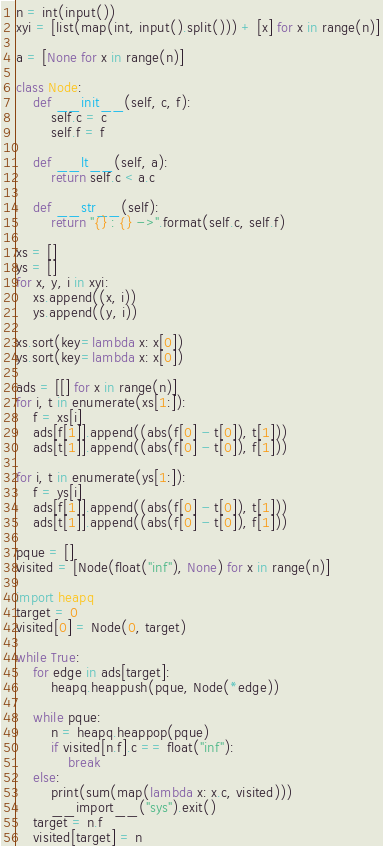<code> <loc_0><loc_0><loc_500><loc_500><_Python_>n = int(input())
xyi = [list(map(int, input().split())) + [x] for x in range(n)]

a = [None for x in range(n)]

class Node:
    def __init__(self, c, f):
        self.c = c
        self.f = f

    def __lt__(self, a):
        return self.c < a.c

    def __str__(self):
        return "{} : {} ->".format(self.c, self.f)

xs = []
ys = []
for x, y, i in xyi:
    xs.append((x, i))
    ys.append((y, i))

xs.sort(key=lambda x: x[0])
ys.sort(key=lambda x: x[0])

ads = [[] for x in range(n)]
for i, t in enumerate(xs[1:]):
    f = xs[i]
    ads[f[1]].append((abs(f[0] - t[0]), t[1]))
    ads[t[1]].append((abs(f[0] - t[0]), f[1]))

for i, t in enumerate(ys[1:]):
    f = ys[i]
    ads[f[1]].append((abs(f[0] - t[0]), t[1]))
    ads[t[1]].append((abs(f[0] - t[0]), f[1]))

pque = []
visited = [Node(float("inf"), None) for x in range(n)]

import heapq
target = 0
visited[0] = Node(0, target)

while True:
    for edge in ads[target]:
        heapq.heappush(pque, Node(*edge))

    while pque:
        n = heapq.heappop(pque)
        if visited[n.f].c == float("inf"):
            break
    else:
        print(sum(map(lambda x: x.c, visited)))
        __import__("sys").exit()
    target = n.f
    visited[target] = n
</code> 